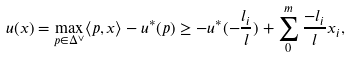Convert formula to latex. <formula><loc_0><loc_0><loc_500><loc_500>u ( x ) = \max _ { p \in \Delta ^ { \vee } } \langle p , x \rangle - u ^ { * } ( p ) \geq - u ^ { * } ( - \frac { l _ { i } } { l } ) + \sum _ { 0 } ^ { m } \frac { - l _ { i } } { l } x _ { i } ,</formula> 